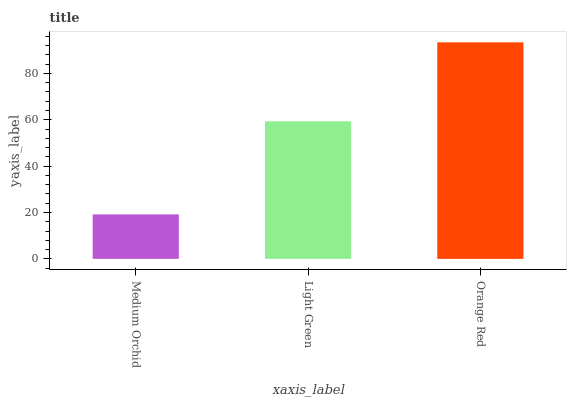Is Medium Orchid the minimum?
Answer yes or no. Yes. Is Orange Red the maximum?
Answer yes or no. Yes. Is Light Green the minimum?
Answer yes or no. No. Is Light Green the maximum?
Answer yes or no. No. Is Light Green greater than Medium Orchid?
Answer yes or no. Yes. Is Medium Orchid less than Light Green?
Answer yes or no. Yes. Is Medium Orchid greater than Light Green?
Answer yes or no. No. Is Light Green less than Medium Orchid?
Answer yes or no. No. Is Light Green the high median?
Answer yes or no. Yes. Is Light Green the low median?
Answer yes or no. Yes. Is Orange Red the high median?
Answer yes or no. No. Is Medium Orchid the low median?
Answer yes or no. No. 